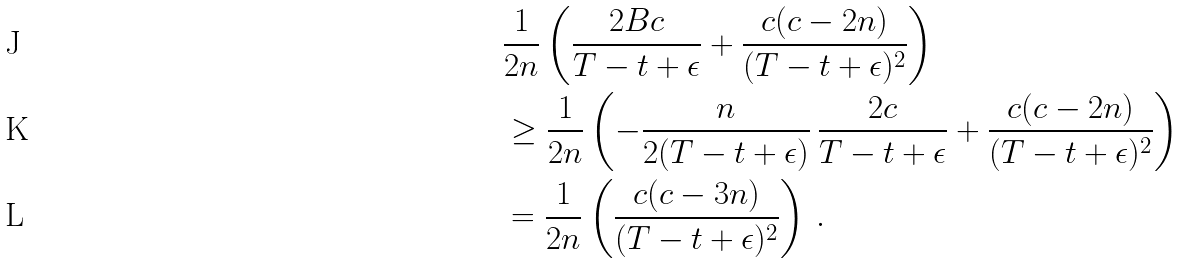<formula> <loc_0><loc_0><loc_500><loc_500>& \frac { 1 } { 2 n } \left ( \frac { 2 B c } { T - t + \epsilon } + \frac { c ( c - 2 n ) } { ( T - t + \epsilon ) ^ { 2 } } \right ) \\ & \geq \frac { 1 } { 2 n } \left ( - \frac { n } { 2 ( T - t + \epsilon ) } \, \frac { 2 c } { T - t + \epsilon } + \frac { c ( c - 2 n ) } { ( T - t + \epsilon ) ^ { 2 } } \right ) \\ & = \frac { 1 } { 2 n } \left ( \frac { c ( c - 3 n ) } { ( T - t + \epsilon ) ^ { 2 } } \right ) \, .</formula> 